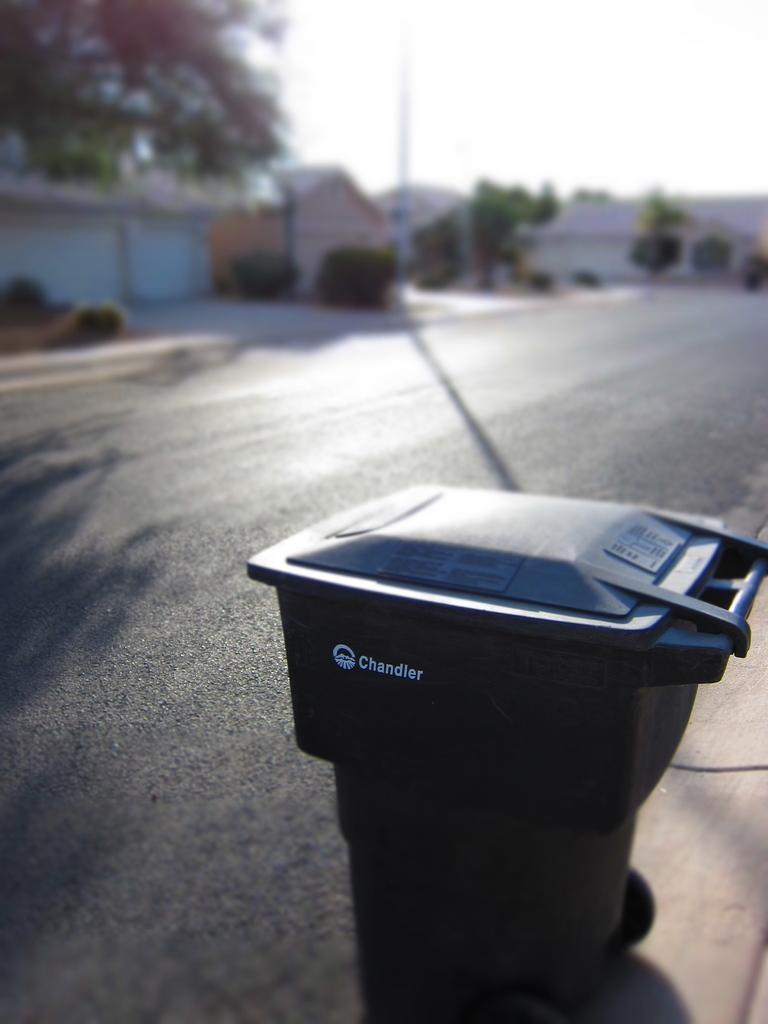How would you summarize this image in a sentence or two? In this image we can see a movable bin. In the background of the image there is a road, trees, plants, houses, pole and the sky. 